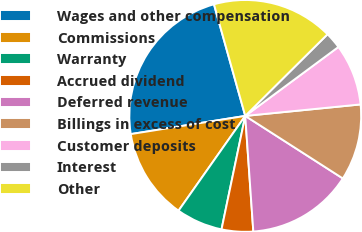Convert chart. <chart><loc_0><loc_0><loc_500><loc_500><pie_chart><fcel>Wages and other compensation<fcel>Commissions<fcel>Warranty<fcel>Accrued dividend<fcel>Deferred revenue<fcel>Billings in excess of cost<fcel>Customer deposits<fcel>Interest<fcel>Other<nl><fcel>23.16%<fcel>12.73%<fcel>6.48%<fcel>4.39%<fcel>14.82%<fcel>10.65%<fcel>8.56%<fcel>2.3%<fcel>16.91%<nl></chart> 